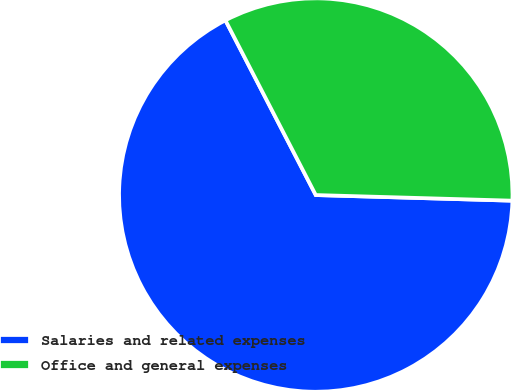Convert chart to OTSL. <chart><loc_0><loc_0><loc_500><loc_500><pie_chart><fcel>Salaries and related expenses<fcel>Office and general expenses<nl><fcel>66.95%<fcel>33.05%<nl></chart> 